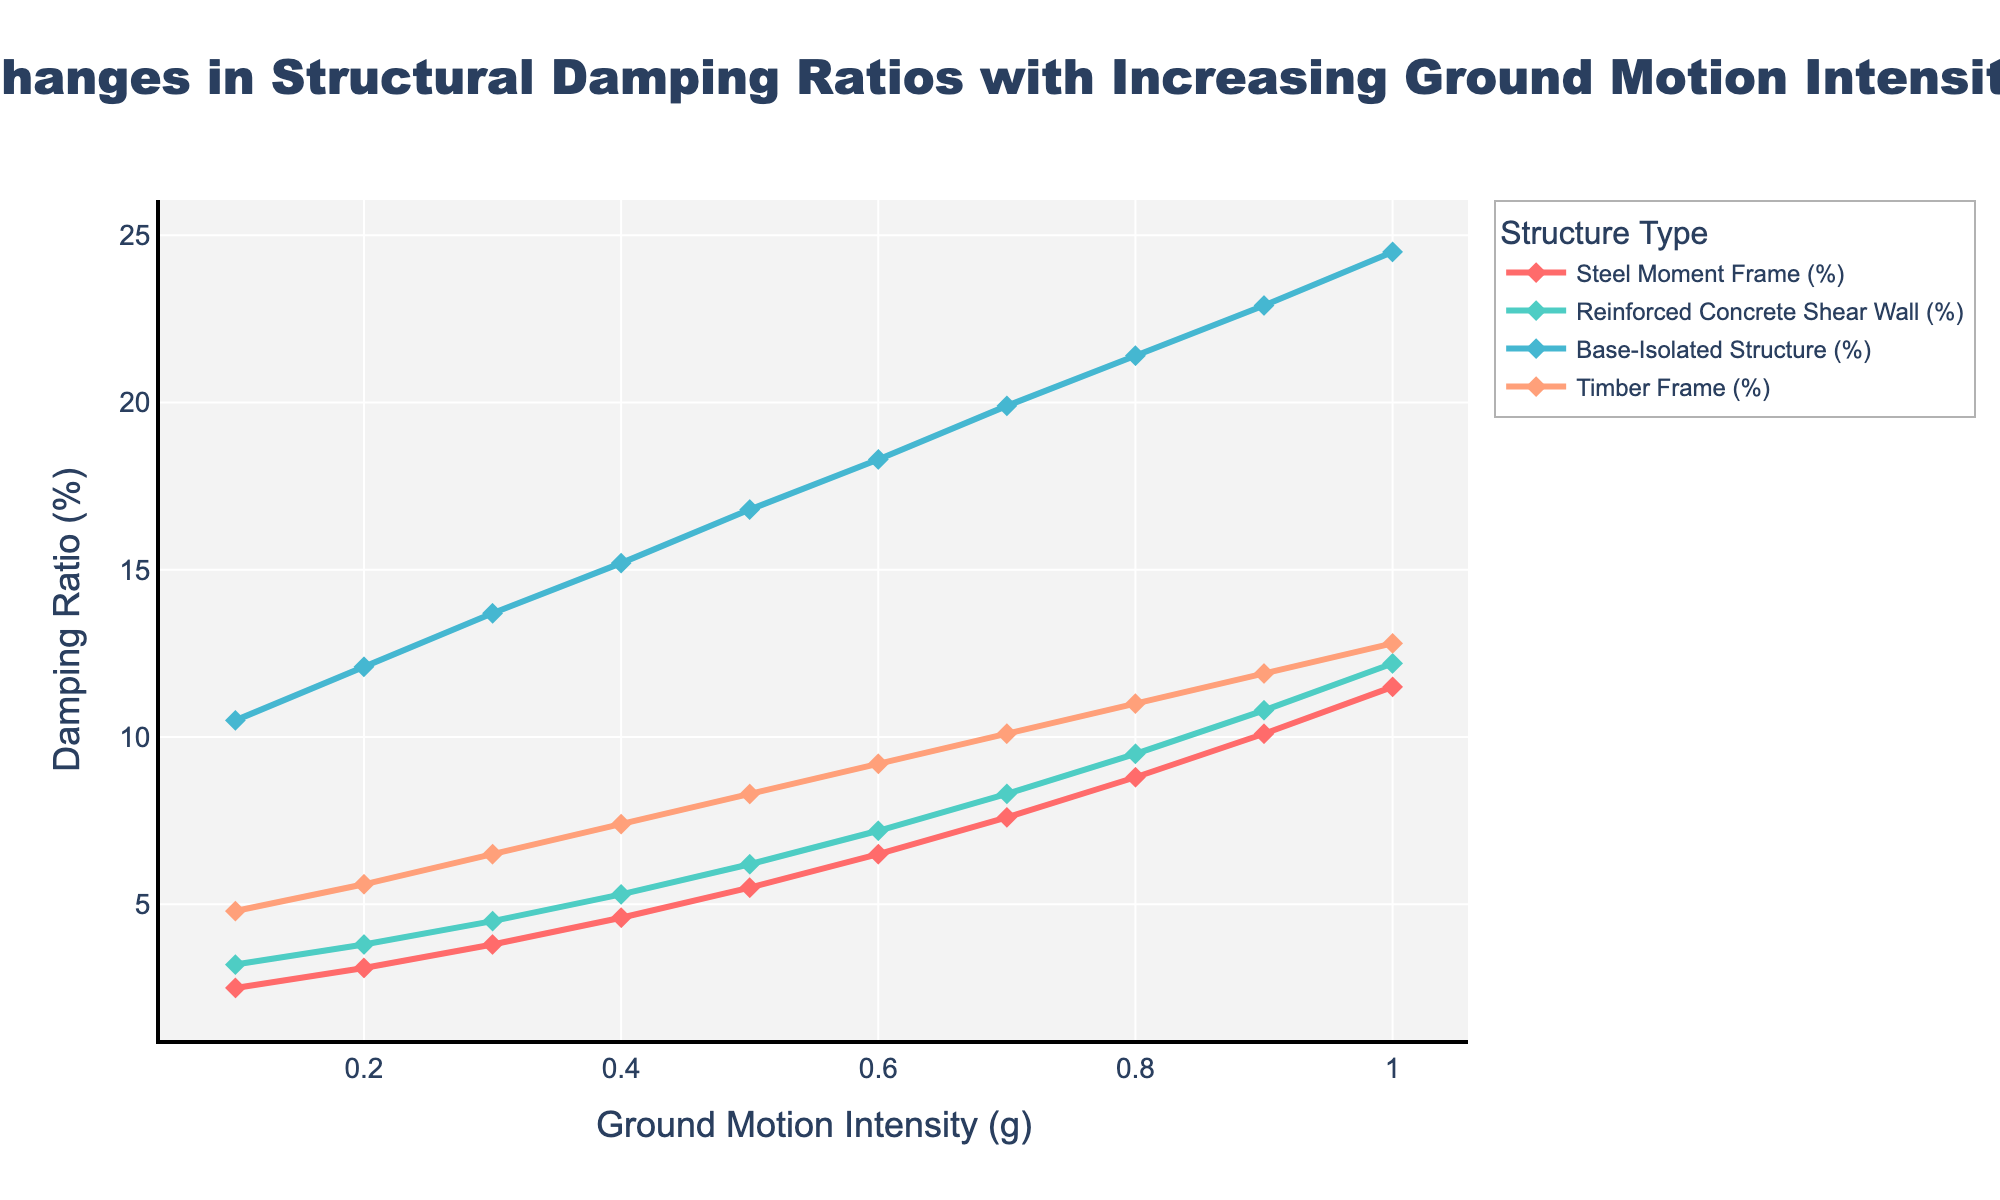Which structure type has the highest damping ratio at a ground motion intensity of 0.3g? At 0.3g ground motion intensity, visually identify which line is highest on the y-axis. The Base-Isolated Structure at approximately 13.7% is the highest.
Answer: Base-Isolated Structure How does the damping ratio of the Steel Moment Frame change as ground motion intensity increases from 0.1g to 1.0g? Locate the Steel Moment Frame values on the plot, track the trend line from 2.5% at 0.1g to 11.5% at 1.0g, and describe the increase.
Answer: It increases gradually Which two structure types have the closest damping ratios at a ground motion intensity of 0.4g? Identify the damping ratios for all structure types at 0.4g: Steel Moment Frame (4.6%), Reinforced Concrete Shear Wall (5.3%), Base-Isolated Structure (15.2%), Timber Frame (7.4%). The closest values are 4.6% and 5.3%.
Answer: Steel Moment Frame and Reinforced Concrete Shear Wall At what ground motion intensity does the Timber Frame's damping ratio reach 10%? Trace the Timber Frame line until it hits 10% on the y-axis, which occurs at around 0.7g.
Answer: 0.7g Compare the rate of increase in damping ratios for Base-Isolated Structure and Timber Frame from 0.5g to 1.0g. Which one increases more? Calculate the difference for each structure: Base-Isolated (24.5% - 16.8% = 7.7%), Timber Frame (12.8% - 8.3% = 4.5%). The Base-Isolated Structure has a higher increase.
Answer: Base-Isolated Structure What is the average damping ratio of the Reinforced Concrete Shear Wall between 0.2g and 0.6g? Sum the damping ratios at 0.2g (3.8%), 0.3g (4.5%), 0.4g (5.3%), 0.5g (6.2%), and 0.6g (7.2%), then divide by 5: (3.8 + 4.5 + 5.3 + 6.2 + 7.2) / 5.
Answer: 5.4% Describe the visual trend for the Base-Isolated Structure as ground motion intensity increases. Follow the Base-Isolated Structure line, which consistently rises from about 10.5% at 0.1g to 24.5% at 1.0g, indicating a steep upward trend.
Answer: Steep upward trend How much higher is the damping ratio of the Steel Moment Frame compared to the Timber Frame at 0.8g? Find both values at 0.8g: Steel Moment Frame (8.8%), Timber Frame (11.0%). Calculate the difference: 11.0% - 8.8%.
Answer: 2.2% Which structure type shows the least change in damping ratio over the entire ground motion intensity range? Compare the range of damping ratios from 0.1g to 1.0g for all structures. Steel Moment Frame ranges from 2.5% to 11.5%, Reinforced Concrete Shear Wall from 3.2% to 12.2%, Base-Isolated Structure from 10.5% to 24.5%, and Timber Frame from 4.8% to 12.8%. The Steel Moment Frame shows the smallest change (11.5% - 2.5% = 9%).
Answer: Steel Moment Frame 